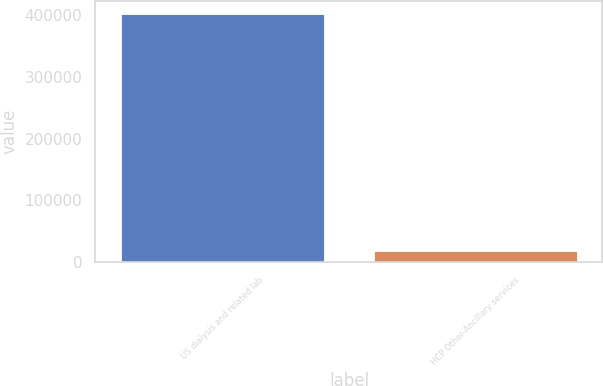Convert chart to OTSL. <chart><loc_0><loc_0><loc_500><loc_500><bar_chart><fcel>US dialysis and related lab<fcel>HCP Other-Ancillary services<nl><fcel>402767<fcel>18683<nl></chart> 